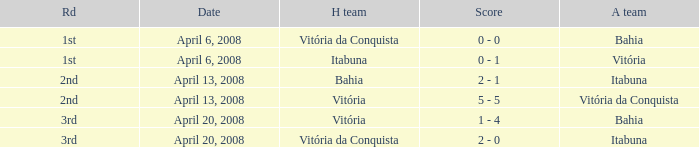What is the name of the home team on April 13, 2008 when Itabuna was the away team? Bahia. 